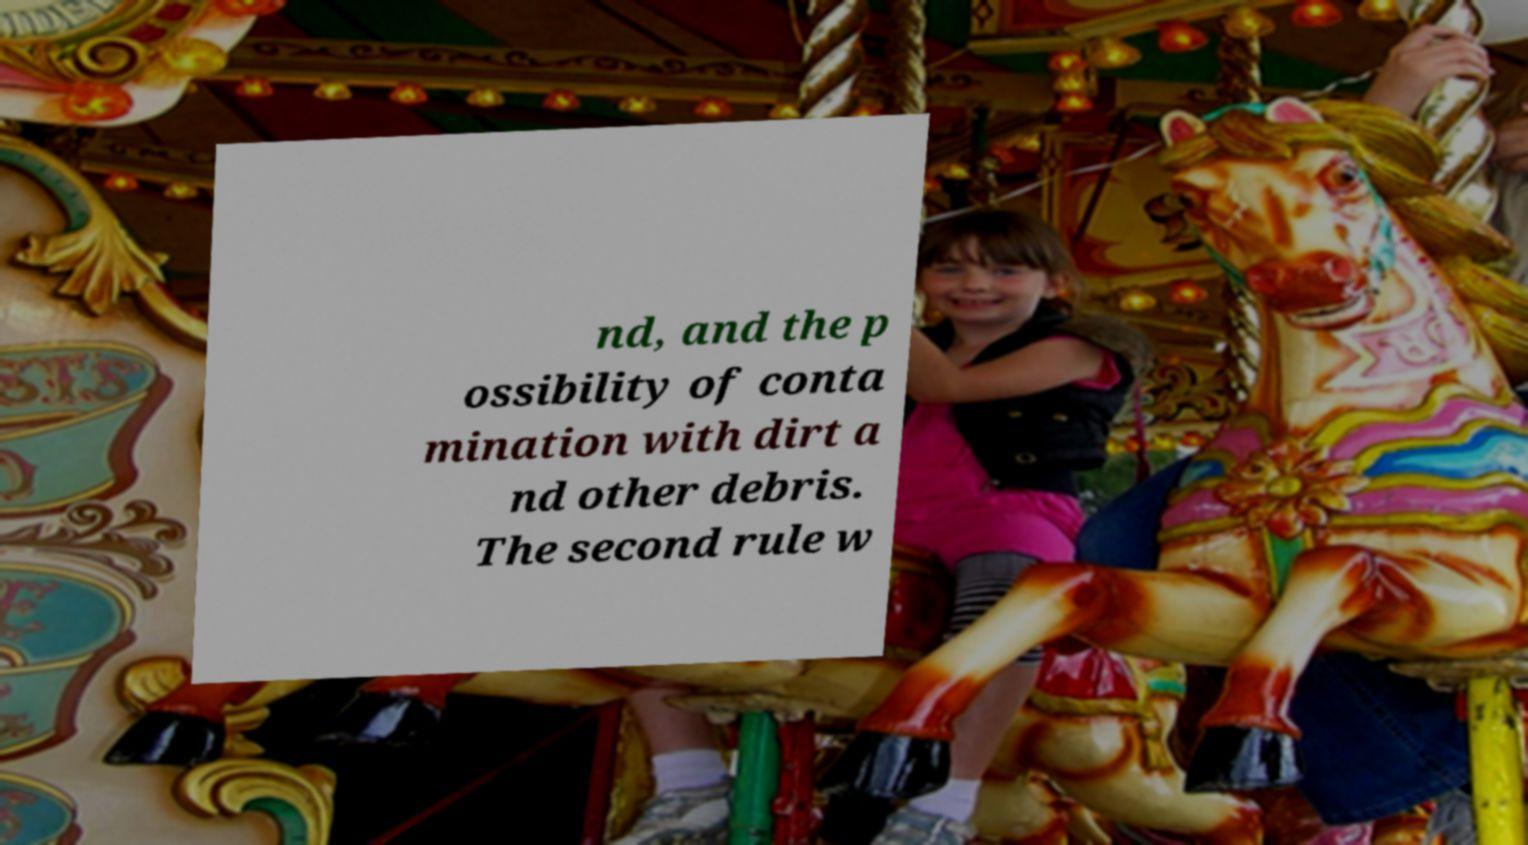Could you extract and type out the text from this image? nd, and the p ossibility of conta mination with dirt a nd other debris. The second rule w 